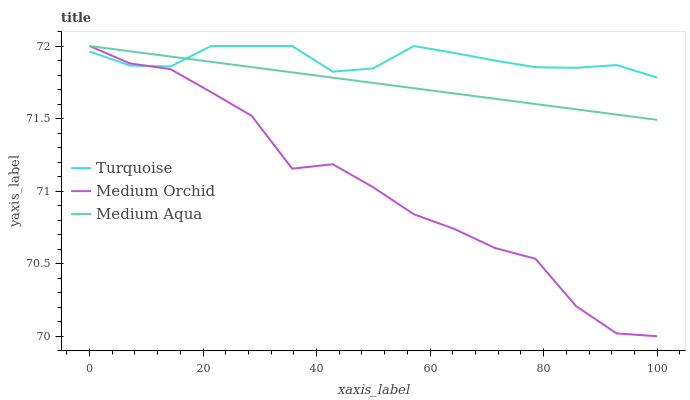Does Medium Orchid have the minimum area under the curve?
Answer yes or no. Yes. Does Turquoise have the maximum area under the curve?
Answer yes or no. Yes. Does Medium Aqua have the minimum area under the curve?
Answer yes or no. No. Does Medium Aqua have the maximum area under the curve?
Answer yes or no. No. Is Medium Aqua the smoothest?
Answer yes or no. Yes. Is Medium Orchid the roughest?
Answer yes or no. Yes. Is Medium Orchid the smoothest?
Answer yes or no. No. Is Medium Aqua the roughest?
Answer yes or no. No. Does Medium Orchid have the lowest value?
Answer yes or no. Yes. Does Medium Aqua have the lowest value?
Answer yes or no. No. Does Medium Aqua have the highest value?
Answer yes or no. Yes. Does Turquoise intersect Medium Orchid?
Answer yes or no. Yes. Is Turquoise less than Medium Orchid?
Answer yes or no. No. Is Turquoise greater than Medium Orchid?
Answer yes or no. No. 